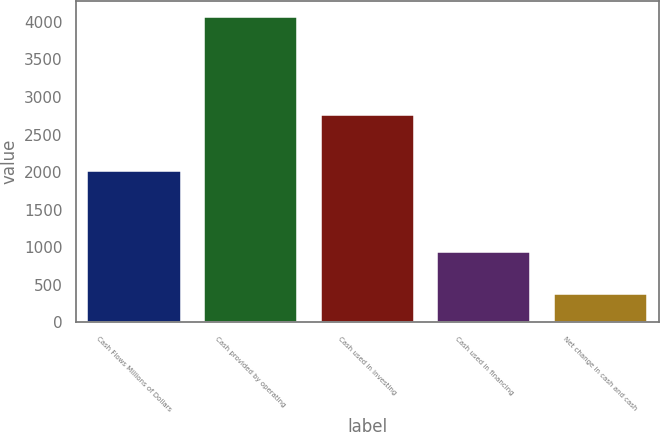<chart> <loc_0><loc_0><loc_500><loc_500><bar_chart><fcel>Cash Flows Millions of Dollars<fcel>Cash provided by operating<fcel>Cash used in investing<fcel>Cash used in financing<fcel>Net change in cash and cash<nl><fcel>2008<fcel>4070<fcel>2764<fcel>935<fcel>371<nl></chart> 